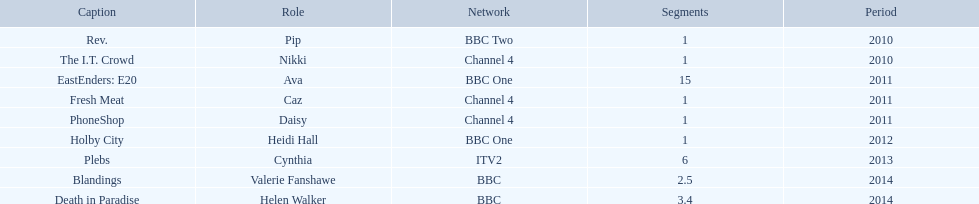Were there more than four episodes that featured cynthia? Yes. 